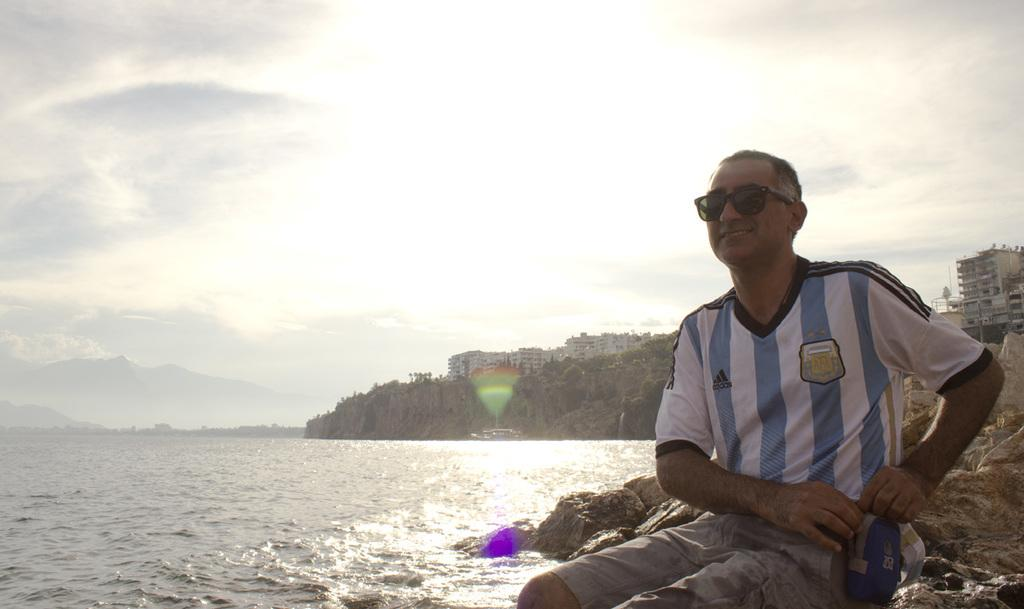Who is present in the image? There is a man in the image. What is the man wearing on his face? The man is wearing goggles. What expression does the man have? The man is smiling. What can be seen in the foreground of the image? There is water visible in the image. What is visible in the background of the image? Buildings, rocks, trees, and the sky are visible in the background of the image. What is the condition of the sky in the image? The sky is visible in the background of the image, and there are clouds present. What type of notebook is the man holding in the image? There is no notebook present in the image. What sense does the man appear to be using while wearing the goggles? The image does not provide information about the man's senses or the purpose of the goggles. 